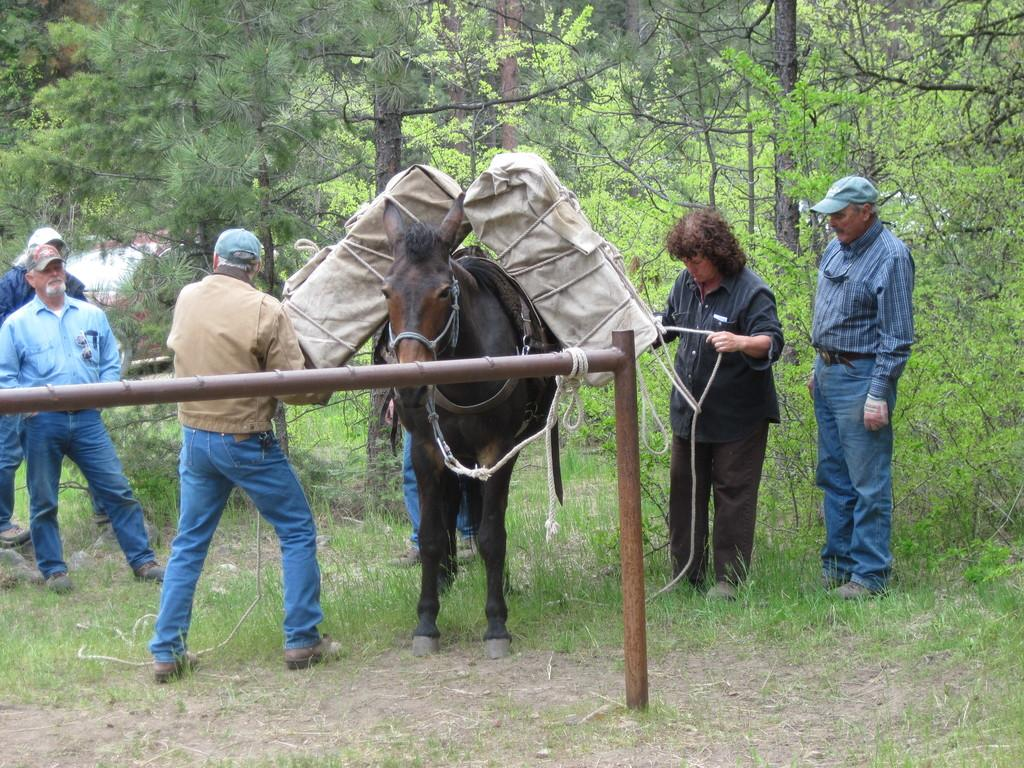What can be seen in the image involving people? There are people standing in the image. What type of living creature is also present in the image? There is an animal in the image. What is on the animal? Objects are present on the animal. What is on the ground in the image? There is a stand on the ground in the image. What can be seen in the distance in the image? Trees are visible in the background of the image. What type of nest can be seen on the ground in the image? There is no nest present on the ground in the image. What smell is associated with the animal in the image? The image does not provide any information about the smell associated with the animal. 